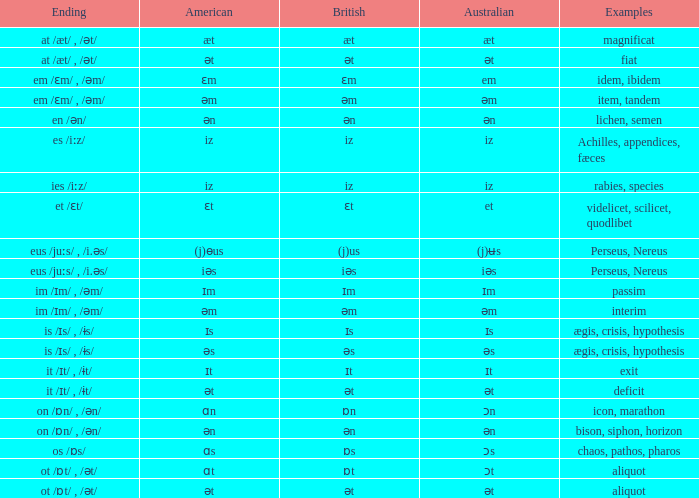Which Examples has Australian of əm? Item, tandem, interim. 